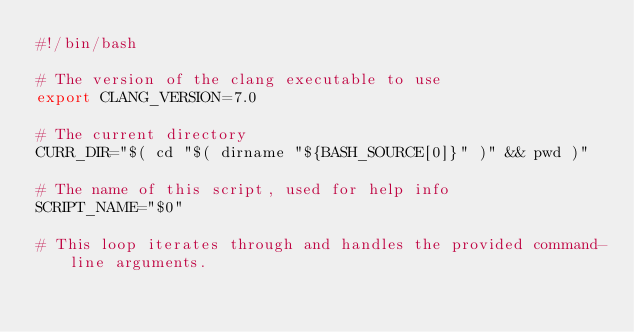Convert code to text. <code><loc_0><loc_0><loc_500><loc_500><_Bash_>#!/bin/bash

# The version of the clang executable to use
export CLANG_VERSION=7.0

# The current directory
CURR_DIR="$( cd "$( dirname "${BASH_SOURCE[0]}" )" && pwd )"

# The name of this script, used for help info
SCRIPT_NAME="$0"

# This loop iterates through and handles the provided command-line arguments.</code> 